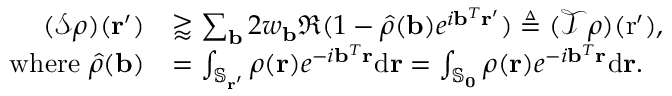Convert formula to latex. <formula><loc_0><loc_0><loc_500><loc_500>\begin{array} { r l } { ( \mathcal { S } \rho ) ( r ^ { \prime } ) } & { \gtrapprox \sum _ { b } 2 w _ { b } \Re ( 1 - \hat { \rho } ( b ) e ^ { i b ^ { T } r ^ { \prime } } ) \triangle q ( \mathcal { T } \rho ) ( r ^ { \prime } ) , } \\ { w h e r e \hat { \rho } ( b ) } & { = \int _ { \mathbb { S } _ { r ^ { \prime } } } \rho ( r ) e ^ { - i b ^ { T } r } d r = \int _ { \mathbb { S } _ { 0 } } \rho ( r ) e ^ { - i b ^ { T } r } d r . } \end{array}</formula> 